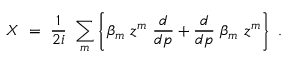<formula> <loc_0><loc_0><loc_500><loc_500>X \ = \ { \frac { 1 } { 2 i } } \ \sum _ { m } \left \{ \beta _ { m } \ z ^ { m } \ { \frac { d } { d p } } + { \frac { d } { d p } } \ \beta _ { m } \ z ^ { m } \right \} \ .</formula> 